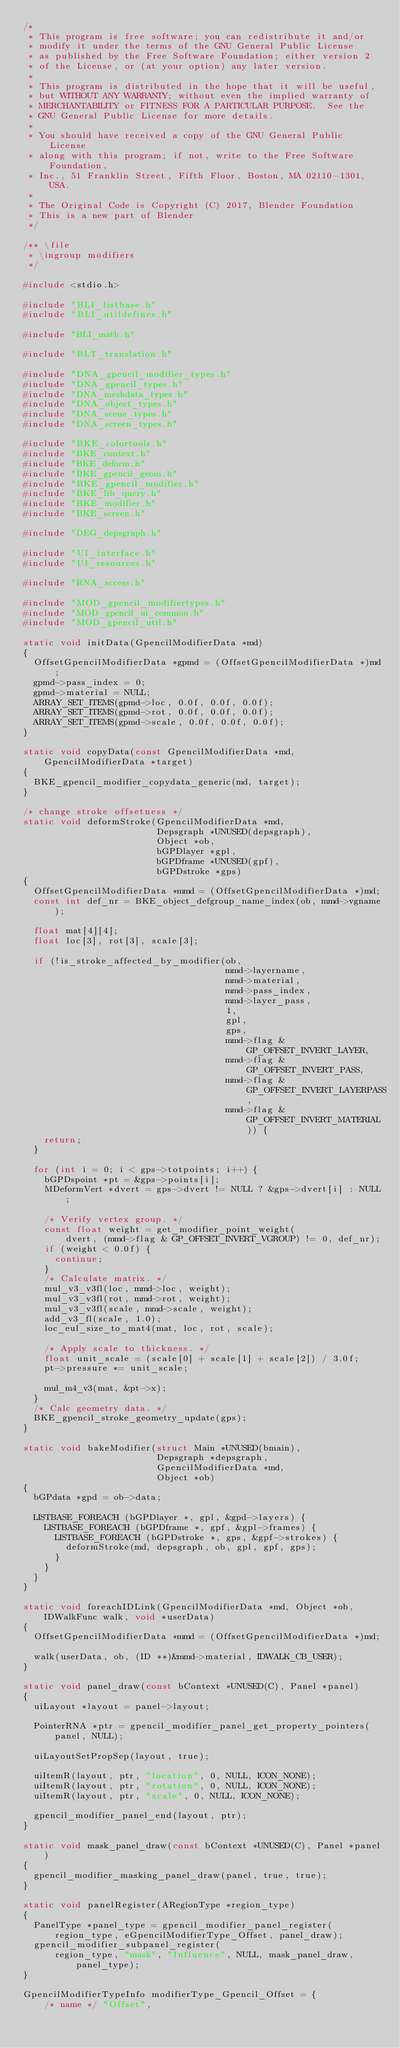Convert code to text. <code><loc_0><loc_0><loc_500><loc_500><_C_>/*
 * This program is free software; you can redistribute it and/or
 * modify it under the terms of the GNU General Public License
 * as published by the Free Software Foundation; either version 2
 * of the License, or (at your option) any later version.
 *
 * This program is distributed in the hope that it will be useful,
 * but WITHOUT ANY WARRANTY; without even the implied warranty of
 * MERCHANTABILITY or FITNESS FOR A PARTICULAR PURPOSE.  See the
 * GNU General Public License for more details.
 *
 * You should have received a copy of the GNU General Public License
 * along with this program; if not, write to the Free Software Foundation,
 * Inc., 51 Franklin Street, Fifth Floor, Boston, MA 02110-1301, USA.
 *
 * The Original Code is Copyright (C) 2017, Blender Foundation
 * This is a new part of Blender
 */

/** \file
 * \ingroup modifiers
 */

#include <stdio.h>

#include "BLI_listbase.h"
#include "BLI_utildefines.h"

#include "BLI_math.h"

#include "BLT_translation.h"

#include "DNA_gpencil_modifier_types.h"
#include "DNA_gpencil_types.h"
#include "DNA_meshdata_types.h"
#include "DNA_object_types.h"
#include "DNA_scene_types.h"
#include "DNA_screen_types.h"

#include "BKE_colortools.h"
#include "BKE_context.h"
#include "BKE_deform.h"
#include "BKE_gpencil_geom.h"
#include "BKE_gpencil_modifier.h"
#include "BKE_lib_query.h"
#include "BKE_modifier.h"
#include "BKE_screen.h"

#include "DEG_depsgraph.h"

#include "UI_interface.h"
#include "UI_resources.h"

#include "RNA_access.h"

#include "MOD_gpencil_modifiertypes.h"
#include "MOD_gpencil_ui_common.h"
#include "MOD_gpencil_util.h"

static void initData(GpencilModifierData *md)
{
  OffsetGpencilModifierData *gpmd = (OffsetGpencilModifierData *)md;
  gpmd->pass_index = 0;
  gpmd->material = NULL;
  ARRAY_SET_ITEMS(gpmd->loc, 0.0f, 0.0f, 0.0f);
  ARRAY_SET_ITEMS(gpmd->rot, 0.0f, 0.0f, 0.0f);
  ARRAY_SET_ITEMS(gpmd->scale, 0.0f, 0.0f, 0.0f);
}

static void copyData(const GpencilModifierData *md, GpencilModifierData *target)
{
  BKE_gpencil_modifier_copydata_generic(md, target);
}

/* change stroke offsetness */
static void deformStroke(GpencilModifierData *md,
                         Depsgraph *UNUSED(depsgraph),
                         Object *ob,
                         bGPDlayer *gpl,
                         bGPDframe *UNUSED(gpf),
                         bGPDstroke *gps)
{
  OffsetGpencilModifierData *mmd = (OffsetGpencilModifierData *)md;
  const int def_nr = BKE_object_defgroup_name_index(ob, mmd->vgname);

  float mat[4][4];
  float loc[3], rot[3], scale[3];

  if (!is_stroke_affected_by_modifier(ob,
                                      mmd->layername,
                                      mmd->material,
                                      mmd->pass_index,
                                      mmd->layer_pass,
                                      1,
                                      gpl,
                                      gps,
                                      mmd->flag & GP_OFFSET_INVERT_LAYER,
                                      mmd->flag & GP_OFFSET_INVERT_PASS,
                                      mmd->flag & GP_OFFSET_INVERT_LAYERPASS,
                                      mmd->flag & GP_OFFSET_INVERT_MATERIAL)) {
    return;
  }

  for (int i = 0; i < gps->totpoints; i++) {
    bGPDspoint *pt = &gps->points[i];
    MDeformVert *dvert = gps->dvert != NULL ? &gps->dvert[i] : NULL;

    /* Verify vertex group. */
    const float weight = get_modifier_point_weight(
        dvert, (mmd->flag & GP_OFFSET_INVERT_VGROUP) != 0, def_nr);
    if (weight < 0.0f) {
      continue;
    }
    /* Calculate matrix. */
    mul_v3_v3fl(loc, mmd->loc, weight);
    mul_v3_v3fl(rot, mmd->rot, weight);
    mul_v3_v3fl(scale, mmd->scale, weight);
    add_v3_fl(scale, 1.0);
    loc_eul_size_to_mat4(mat, loc, rot, scale);

    /* Apply scale to thickness. */
    float unit_scale = (scale[0] + scale[1] + scale[2]) / 3.0f;
    pt->pressure *= unit_scale;

    mul_m4_v3(mat, &pt->x);
  }
  /* Calc geometry data. */
  BKE_gpencil_stroke_geometry_update(gps);
}

static void bakeModifier(struct Main *UNUSED(bmain),
                         Depsgraph *depsgraph,
                         GpencilModifierData *md,
                         Object *ob)
{
  bGPdata *gpd = ob->data;

  LISTBASE_FOREACH (bGPDlayer *, gpl, &gpd->layers) {
    LISTBASE_FOREACH (bGPDframe *, gpf, &gpl->frames) {
      LISTBASE_FOREACH (bGPDstroke *, gps, &gpf->strokes) {
        deformStroke(md, depsgraph, ob, gpl, gpf, gps);
      }
    }
  }
}

static void foreachIDLink(GpencilModifierData *md, Object *ob, IDWalkFunc walk, void *userData)
{
  OffsetGpencilModifierData *mmd = (OffsetGpencilModifierData *)md;

  walk(userData, ob, (ID **)&mmd->material, IDWALK_CB_USER);
}

static void panel_draw(const bContext *UNUSED(C), Panel *panel)
{
  uiLayout *layout = panel->layout;

  PointerRNA *ptr = gpencil_modifier_panel_get_property_pointers(panel, NULL);

  uiLayoutSetPropSep(layout, true);

  uiItemR(layout, ptr, "location", 0, NULL, ICON_NONE);
  uiItemR(layout, ptr, "rotation", 0, NULL, ICON_NONE);
  uiItemR(layout, ptr, "scale", 0, NULL, ICON_NONE);

  gpencil_modifier_panel_end(layout, ptr);
}

static void mask_panel_draw(const bContext *UNUSED(C), Panel *panel)
{
  gpencil_modifier_masking_panel_draw(panel, true, true);
}

static void panelRegister(ARegionType *region_type)
{
  PanelType *panel_type = gpencil_modifier_panel_register(
      region_type, eGpencilModifierType_Offset, panel_draw);
  gpencil_modifier_subpanel_register(
      region_type, "mask", "Influence", NULL, mask_panel_draw, panel_type);
}

GpencilModifierTypeInfo modifierType_Gpencil_Offset = {
    /* name */ "Offset",</code> 